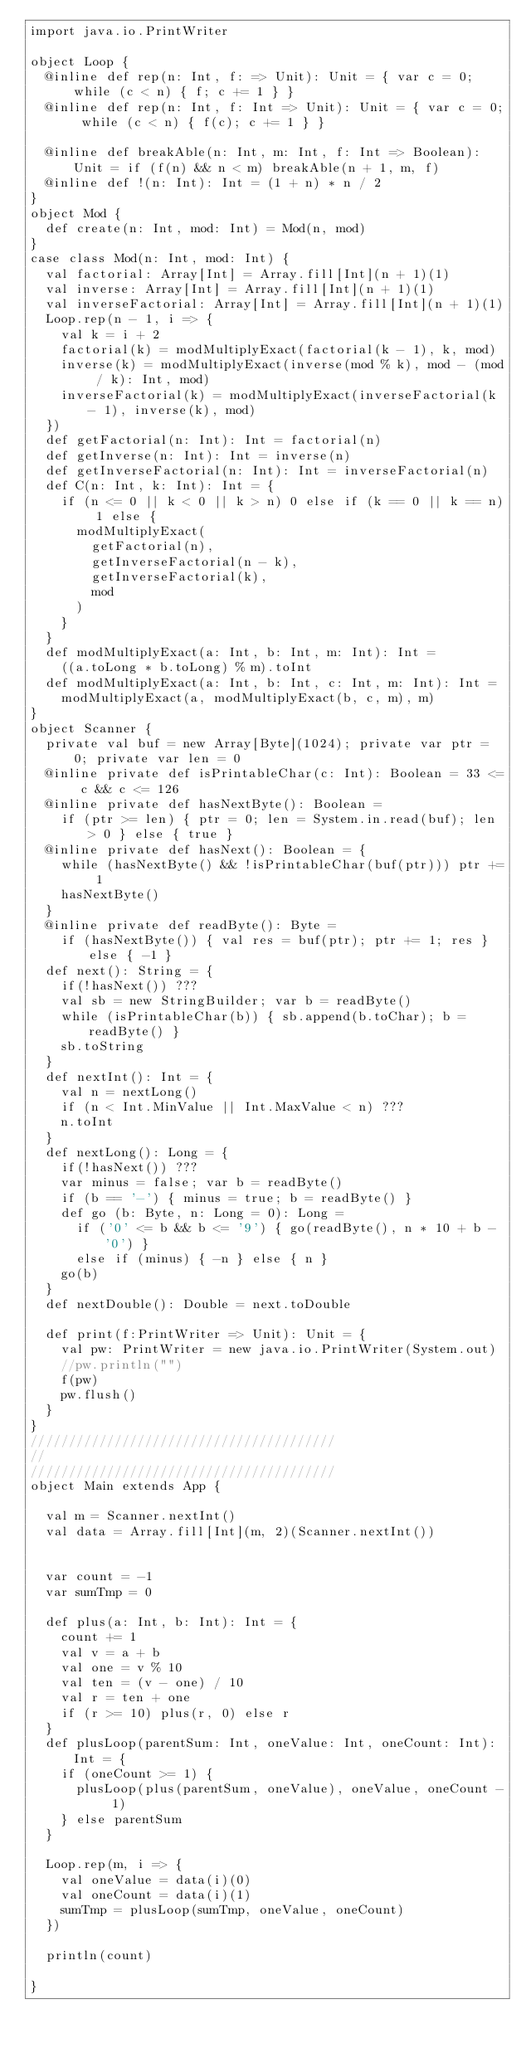<code> <loc_0><loc_0><loc_500><loc_500><_Scala_>import java.io.PrintWriter

object Loop {
  @inline def rep(n: Int, f: => Unit): Unit = { var c = 0; while (c < n) { f; c += 1 } }
  @inline def rep(n: Int, f: Int => Unit): Unit = { var c = 0; while (c < n) { f(c); c += 1 } }

  @inline def breakAble(n: Int, m: Int, f: Int => Boolean): Unit = if (f(n) && n < m) breakAble(n + 1, m, f)
  @inline def !(n: Int): Int = (1 + n) * n / 2
}
object Mod {
  def create(n: Int, mod: Int) = Mod(n, mod)
}
case class Mod(n: Int, mod: Int) {
  val factorial: Array[Int] = Array.fill[Int](n + 1)(1)
  val inverse: Array[Int] = Array.fill[Int](n + 1)(1)
  val inverseFactorial: Array[Int] = Array.fill[Int](n + 1)(1)
  Loop.rep(n - 1, i => {
    val k = i + 2
    factorial(k) = modMultiplyExact(factorial(k - 1), k, mod)
    inverse(k) = modMultiplyExact(inverse(mod % k), mod - (mod / k): Int, mod)
    inverseFactorial(k) = modMultiplyExact(inverseFactorial(k - 1), inverse(k), mod)
  })
  def getFactorial(n: Int): Int = factorial(n)
  def getInverse(n: Int): Int = inverse(n)
  def getInverseFactorial(n: Int): Int = inverseFactorial(n)
  def C(n: Int, k: Int): Int = {
    if (n <= 0 || k < 0 || k > n) 0 else if (k == 0 || k == n) 1 else {
      modMultiplyExact(
        getFactorial(n),
        getInverseFactorial(n - k),
        getInverseFactorial(k),
        mod
      )
    }
  }
  def modMultiplyExact(a: Int, b: Int, m: Int): Int =
    ((a.toLong * b.toLong) % m).toInt
  def modMultiplyExact(a: Int, b: Int, c: Int, m: Int): Int =
    modMultiplyExact(a, modMultiplyExact(b, c, m), m)
}
object Scanner {
  private val buf = new Array[Byte](1024); private var ptr = 0; private var len = 0
  @inline private def isPrintableChar(c: Int): Boolean = 33 <= c && c <= 126
  @inline private def hasNextByte(): Boolean =
    if (ptr >= len) { ptr = 0; len = System.in.read(buf); len > 0 } else { true }
  @inline private def hasNext(): Boolean = {
    while (hasNextByte() && !isPrintableChar(buf(ptr))) ptr += 1
    hasNextByte()
  }
  @inline private def readByte(): Byte =
    if (hasNextByte()) { val res = buf(ptr); ptr += 1; res } else { -1 }
  def next(): String = {
    if(!hasNext()) ???
    val sb = new StringBuilder; var b = readByte()
    while (isPrintableChar(b)) { sb.append(b.toChar); b = readByte() }
    sb.toString
  }
  def nextInt(): Int = {
    val n = nextLong()
    if (n < Int.MinValue || Int.MaxValue < n) ???
    n.toInt
  }
  def nextLong(): Long = {
    if(!hasNext()) ???
    var minus = false; var b = readByte()
    if (b == '-') { minus = true; b = readByte() }
    def go (b: Byte, n: Long = 0): Long =
      if ('0' <= b && b <= '9') { go(readByte(), n * 10 + b - '0') }
      else if (minus) { -n } else { n }
    go(b)
  }
  def nextDouble(): Double = next.toDouble

  def print(f:PrintWriter => Unit): Unit = {
    val pw: PrintWriter = new java.io.PrintWriter(System.out)
    //pw.println("")
    f(pw)
    pw.flush()
  }
}
////////////////////////////////////////
//
////////////////////////////////////////
object Main extends App {

  val m = Scanner.nextInt()
  val data = Array.fill[Int](m, 2)(Scanner.nextInt())


  var count = -1
  var sumTmp = 0

  def plus(a: Int, b: Int): Int = {
    count += 1
    val v = a + b
    val one = v % 10
    val ten = (v - one) / 10
    val r = ten + one
    if (r >= 10) plus(r, 0) else r
  }
  def plusLoop(parentSum: Int, oneValue: Int, oneCount: Int): Int = {
    if (oneCount >= 1) {
      plusLoop(plus(parentSum, oneValue), oneValue, oneCount - 1)
    } else parentSum
  }

  Loop.rep(m, i => {
    val oneValue = data(i)(0)
    val oneCount = data(i)(1)
    sumTmp = plusLoop(sumTmp, oneValue, oneCount)
  })

  println(count)

}</code> 